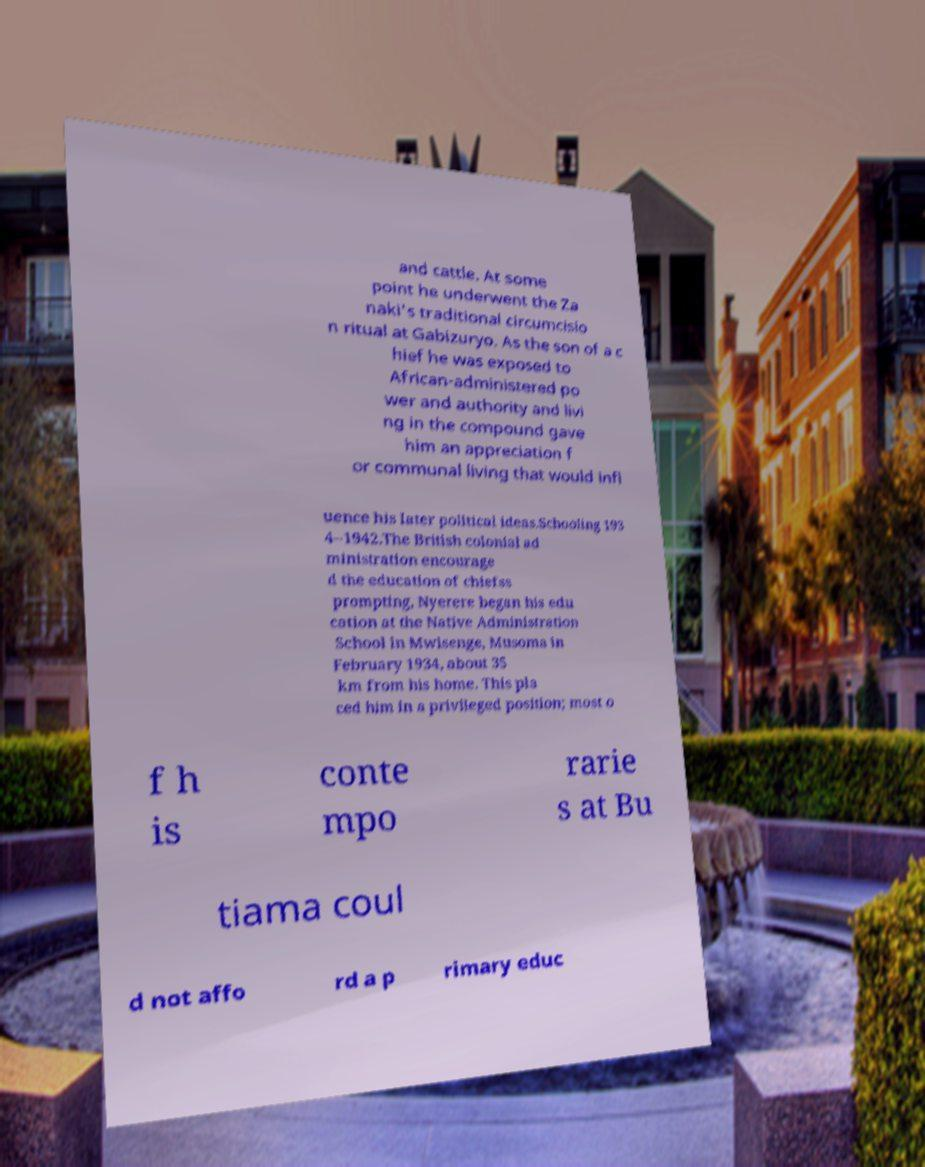Could you extract and type out the text from this image? and cattle. At some point he underwent the Za naki's traditional circumcisio n ritual at Gabizuryo. As the son of a c hief he was exposed to African-administered po wer and authority and livi ng in the compound gave him an appreciation f or communal living that would infl uence his later political ideas.Schooling 193 4–1942.The British colonial ad ministration encourage d the education of chiefss prompting, Nyerere began his edu cation at the Native Administration School in Mwisenge, Musoma in February 1934, about 35 km from his home. This pla ced him in a privileged position; most o f h is conte mpo rarie s at Bu tiama coul d not affo rd a p rimary educ 